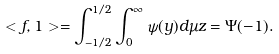Convert formula to latex. <formula><loc_0><loc_0><loc_500><loc_500>< f , 1 > = \int ^ { 1 / 2 } _ { - 1 / 2 } \int _ { 0 } ^ { \infty } \psi ( y ) d \mu z = \Psi ( - 1 ) .</formula> 